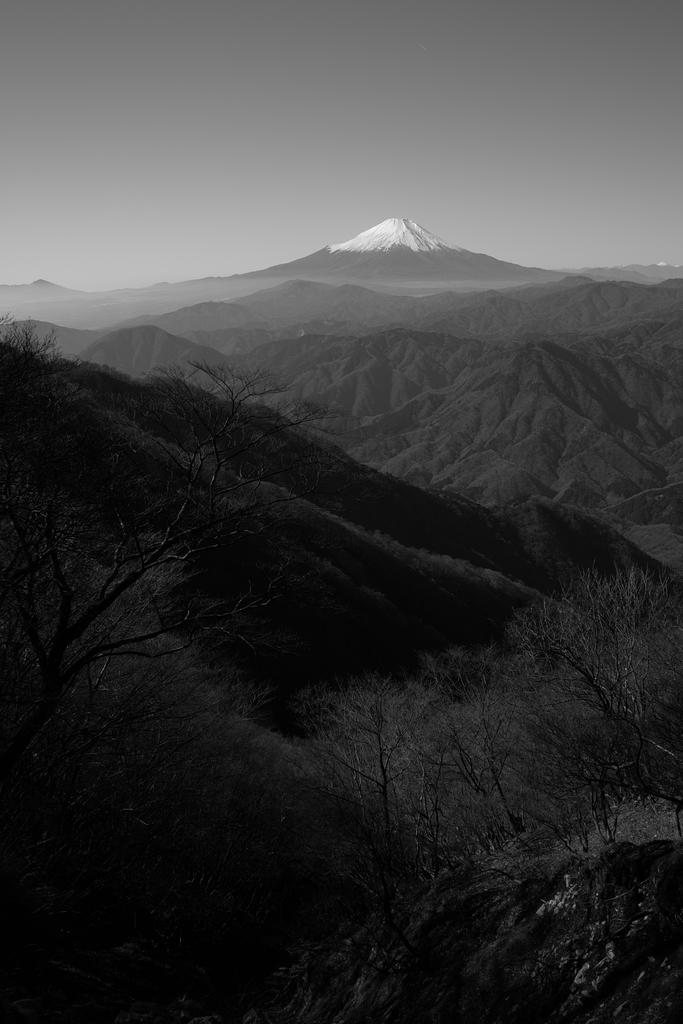What is the color scheme of the image? The image is black and white. What type of natural elements can be seen in the image? There are trees and hills visible in the image. What part of the natural environment is visible in the image? The sky is visible in the image. Can you see any details of the rail in the image? There is no rail present in the image. Is there any indication of thunder in the image? There is no indication of thunder in the image, as it is a black and white image featuring trees, hills, and the sky. 